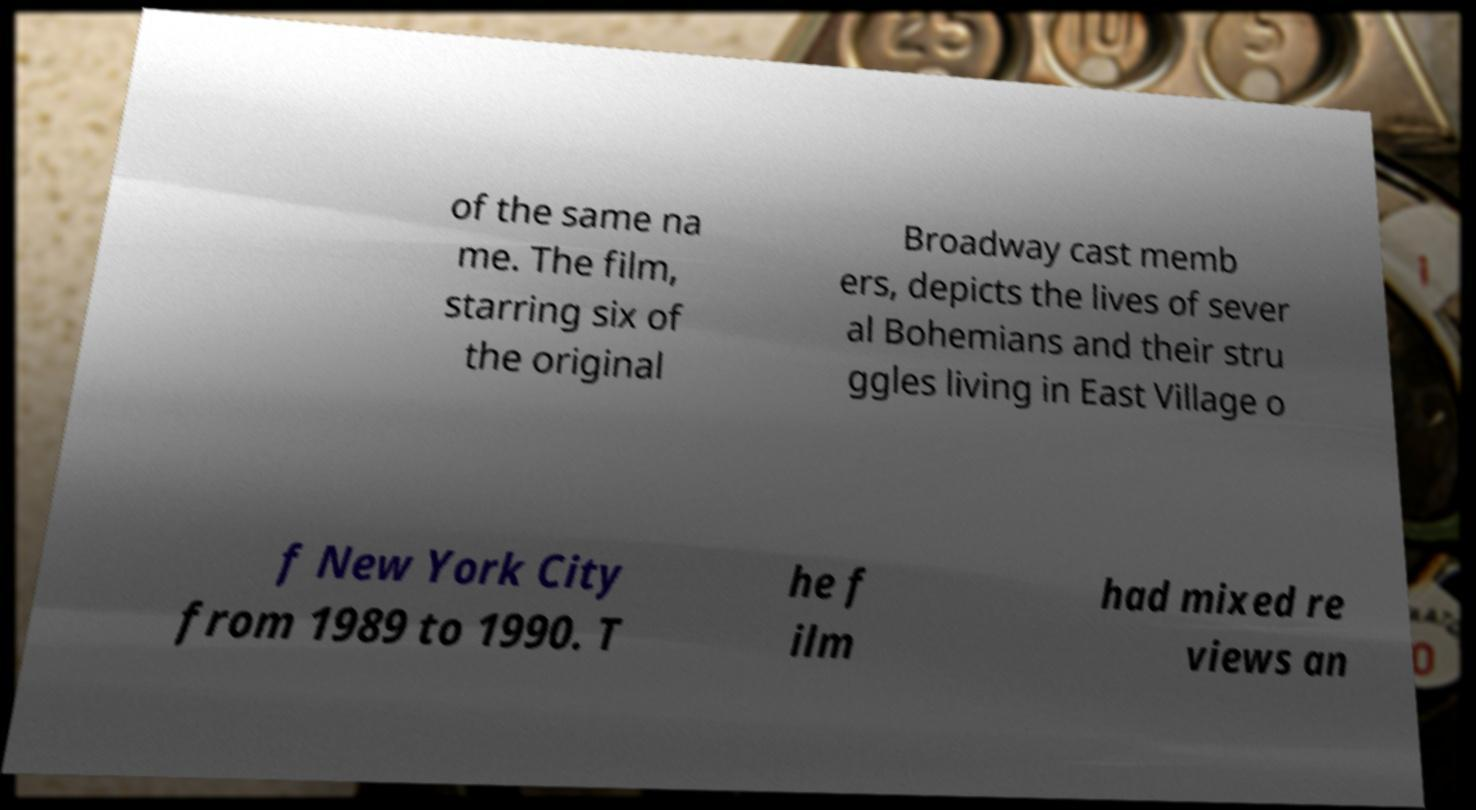Please identify and transcribe the text found in this image. of the same na me. The film, starring six of the original Broadway cast memb ers, depicts the lives of sever al Bohemians and their stru ggles living in East Village o f New York City from 1989 to 1990. T he f ilm had mixed re views an 